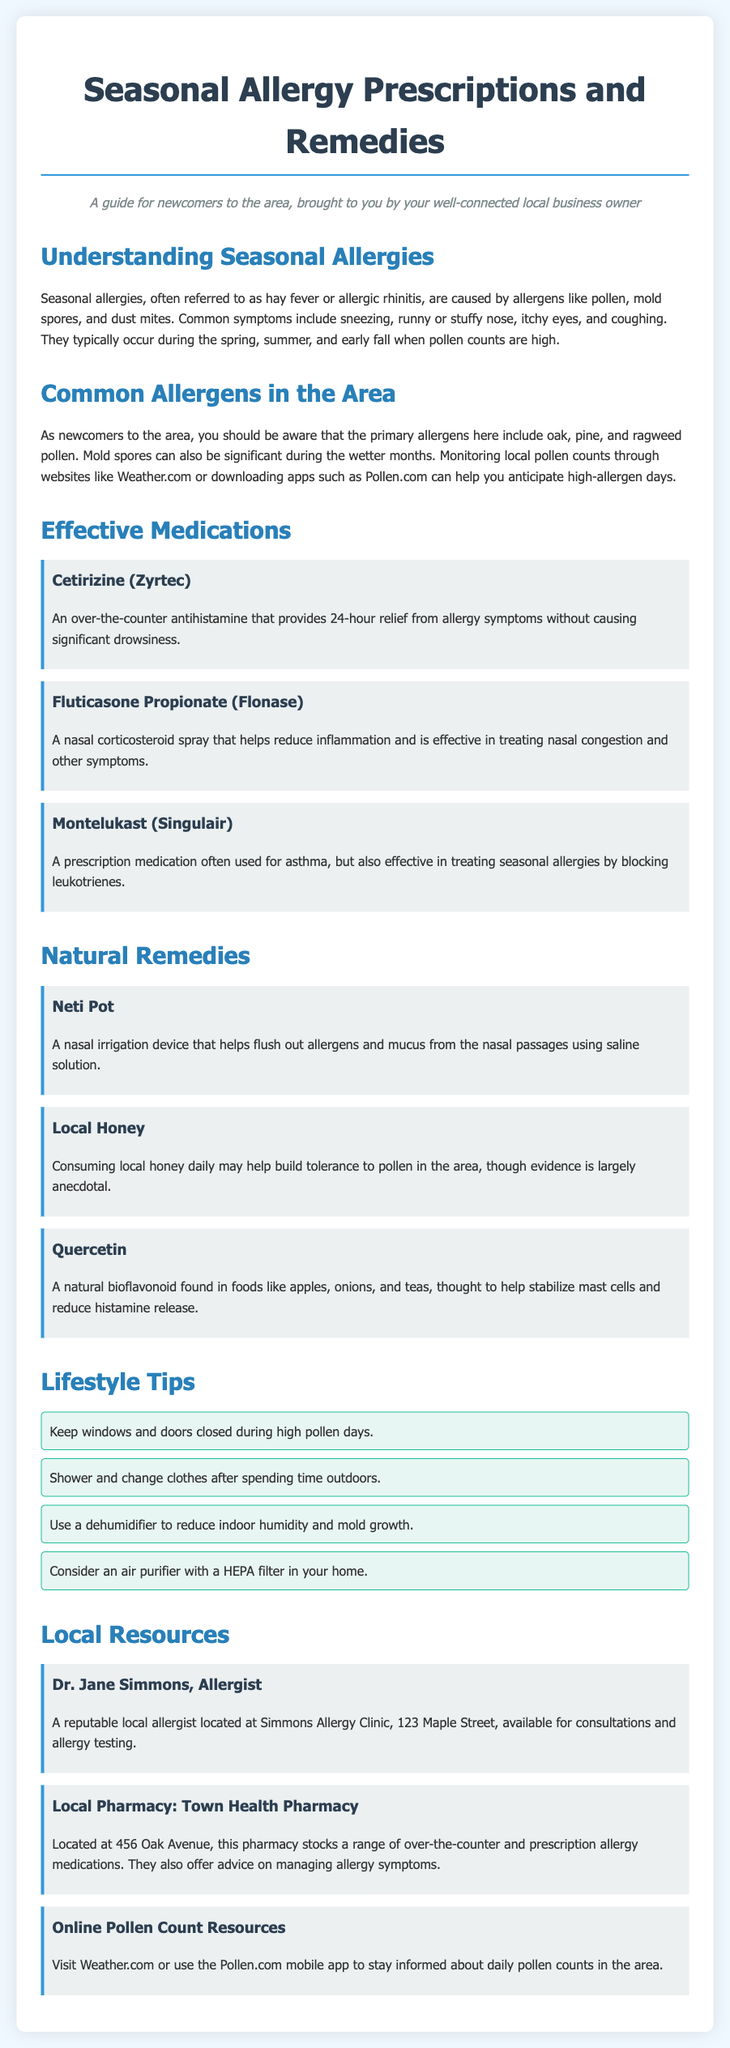What are seasonal allergies also known as? Seasonal allergies are often referred to as hay fever or allergic rhinitis, as mentioned in the document.
Answer: hay fever What is the primary pollen allergen mentioned? The document specifies that the primary allergens include oak, pine, and ragweed pollen.
Answer: oak, pine, and ragweed What type of medication is Cetirizine? The document indicates that Cetirizine is an over-the-counter antihistamine.
Answer: over-the-counter antihistamine What is a natural remedy suggested in the document? Among the natural remedies listed, one example is using a Neti Pot for nasal irrigation.
Answer: Neti Pot What should you do after spending time outdoors? The document suggests showering and changing clothes after spending time outdoors.
Answer: shower and change clothes How many lifestyle tips are provided? The document lists a total of four lifestyle tips for managing seasonal allergies.
Answer: four What is the location of Town Health Pharmacy? The document states that Town Health Pharmacy is located at 456 Oak Avenue.
Answer: 456 Oak Avenue Who is a local allergist mentioned in the document? Dr. Jane Simmons is identified as a reputable local allergist in the document.
Answer: Dr. Jane Simmons What mobile app can help track pollen counts? The document mentions using the Pollen.com mobile app to stay informed about daily pollen counts.
Answer: Pollen.com 